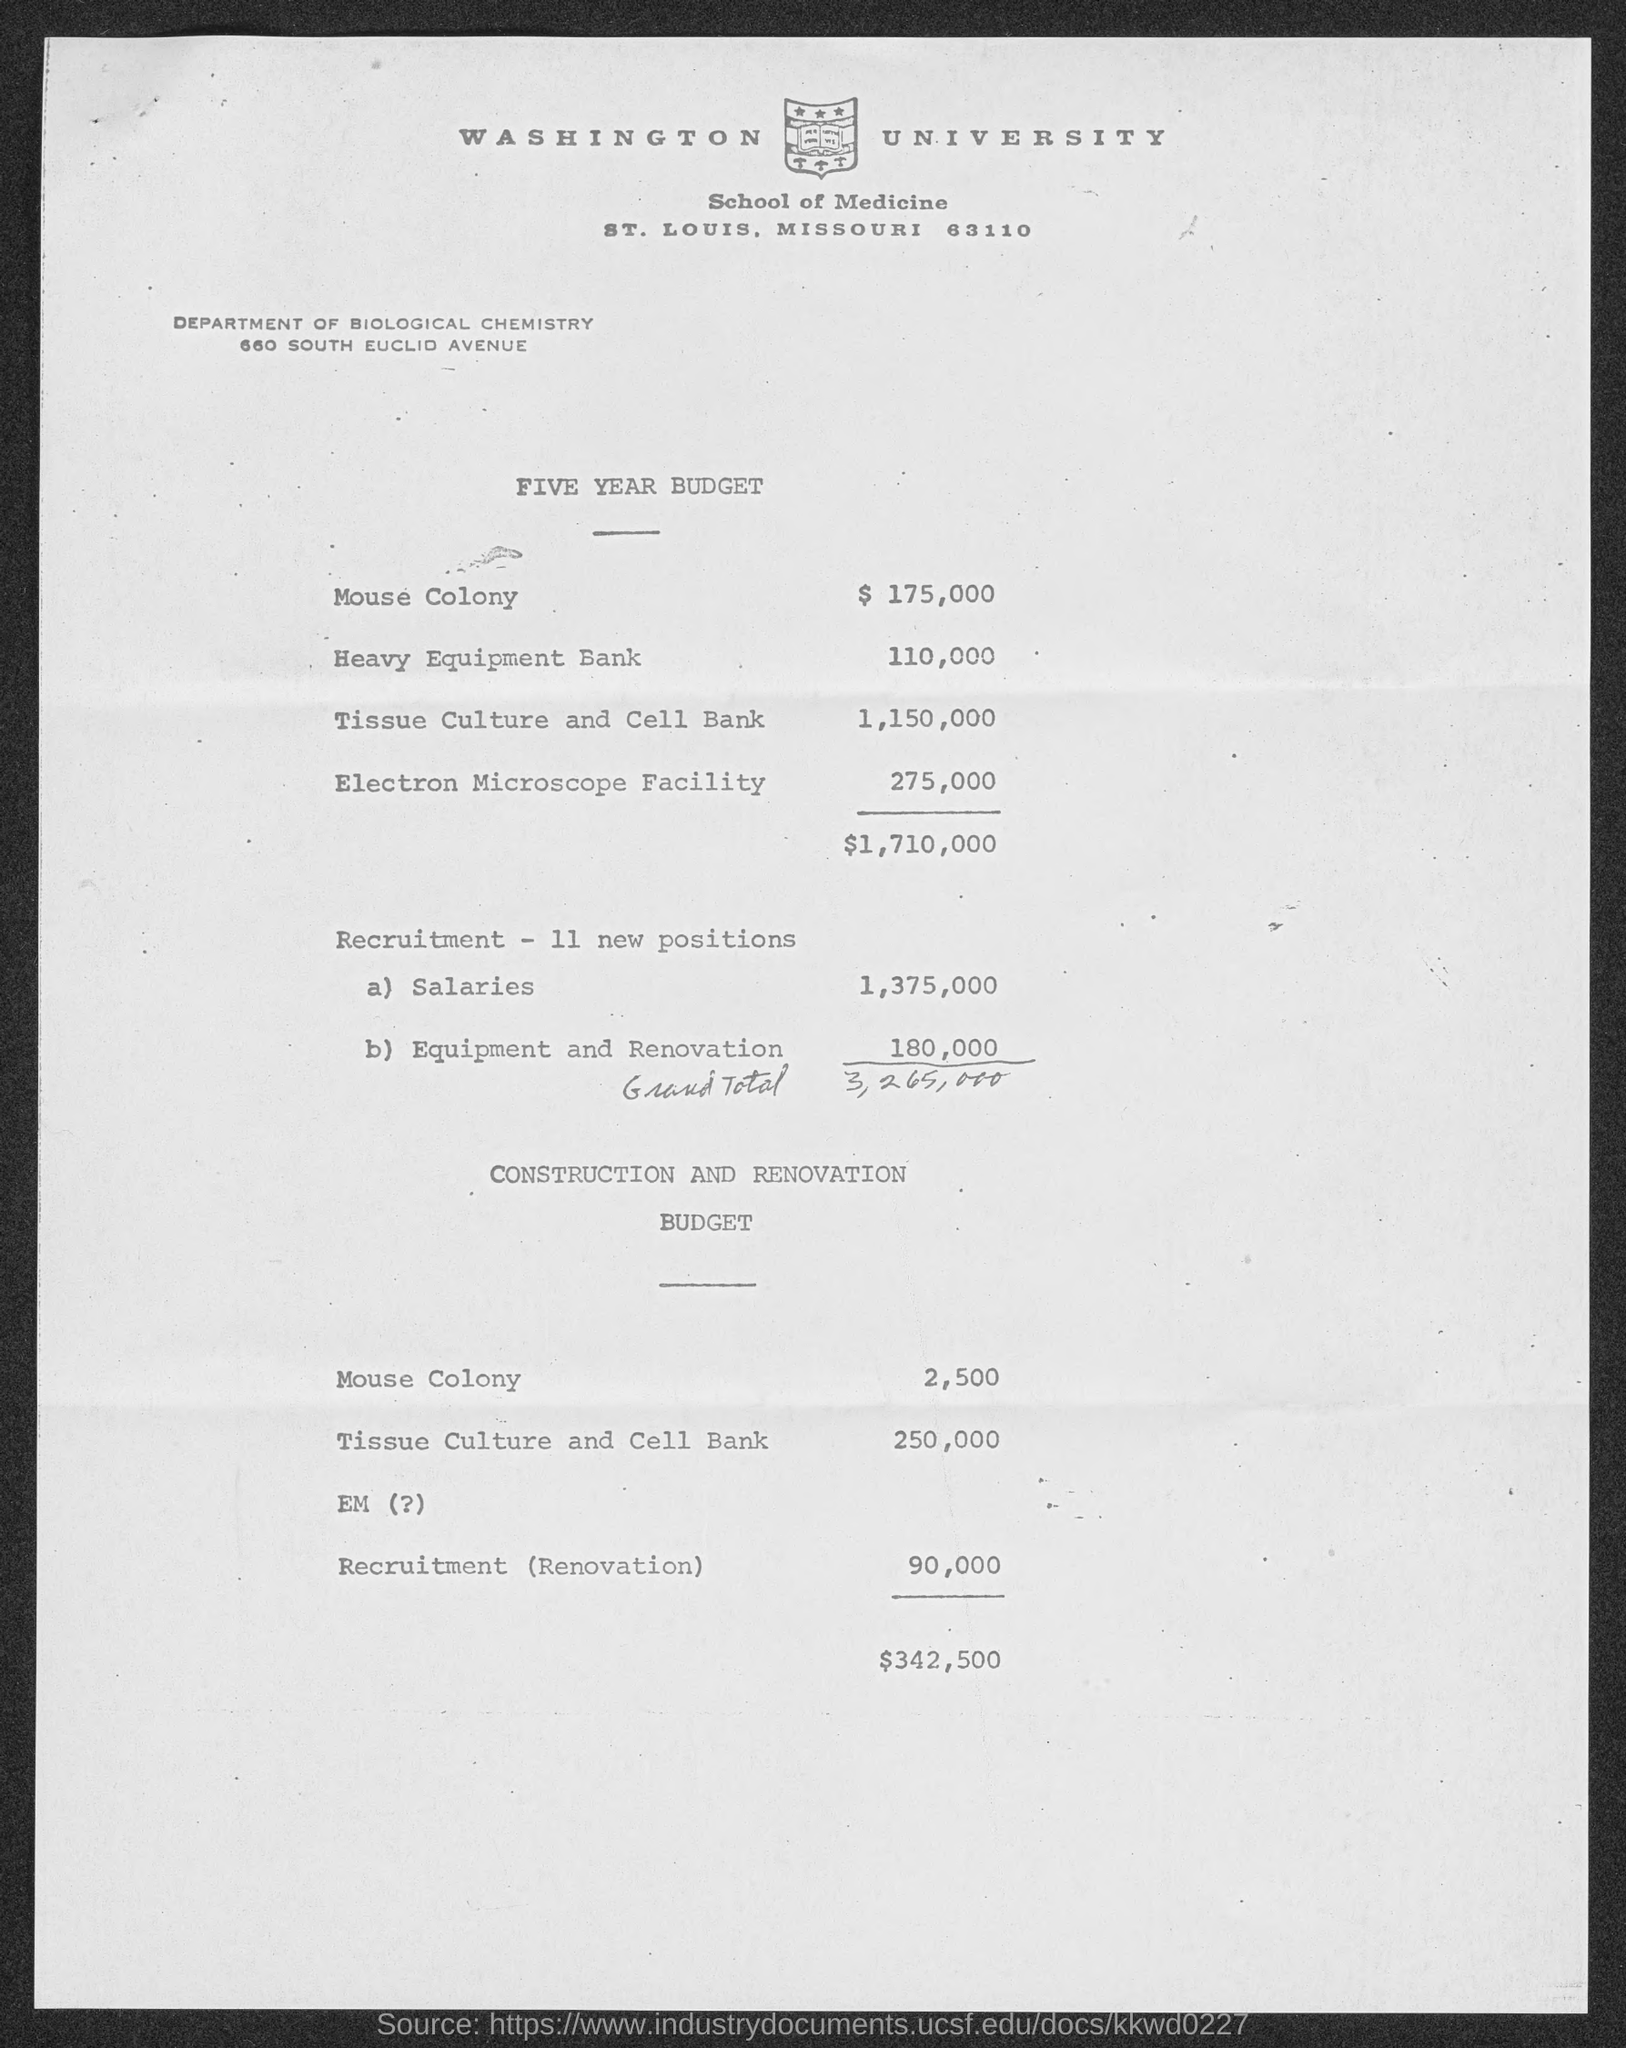What is the name of the university mentioned in the given page ?
Provide a short and direct response. WASHINGTON UNIVERSITY. What is the amount of five year budget for mouse colony ?
Give a very brief answer. $ 175,000. What is the amount of five year budget for heavy equipment bank ?
Provide a succinct answer. 110,000. What is the amount of five year budget for tissue culture and cell bank ?
Make the answer very short. 1,150,000. What is the amount of five year budget for electron microscope facility ?
Provide a short and direct response. 275,000. What is the amount of salaries mentioned in the given budget ?
Provide a succinct answer. 1,375,000. What is the amount of equipment and renovation mentioned in the given budget ?
Your answer should be very brief. 180,000. What is the name of the department mentioned in the given page ?
Ensure brevity in your answer.  Department of biological chemistry. What is the amount given for mouse colony in construction and renovation budget?
Provide a short and direct response. 2,500. 